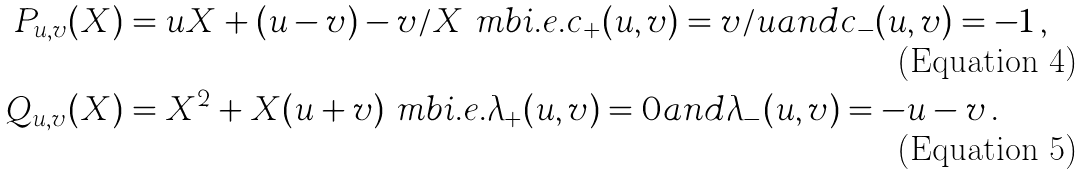<formula> <loc_0><loc_0><loc_500><loc_500>P _ { u , v } ( X ) & = u X + ( u - v ) - v / X \ m b { i . e . } c _ { + } ( u , v ) = v / u a n d c _ { - } ( u , v ) = - 1 \, , \\ Q _ { u , v } ( X ) & = X ^ { 2 } + X ( u + v ) \ m b { i . e . } \lambda _ { + } ( u , v ) = 0 a n d \lambda _ { - } ( u , v ) = - u - v \, .</formula> 